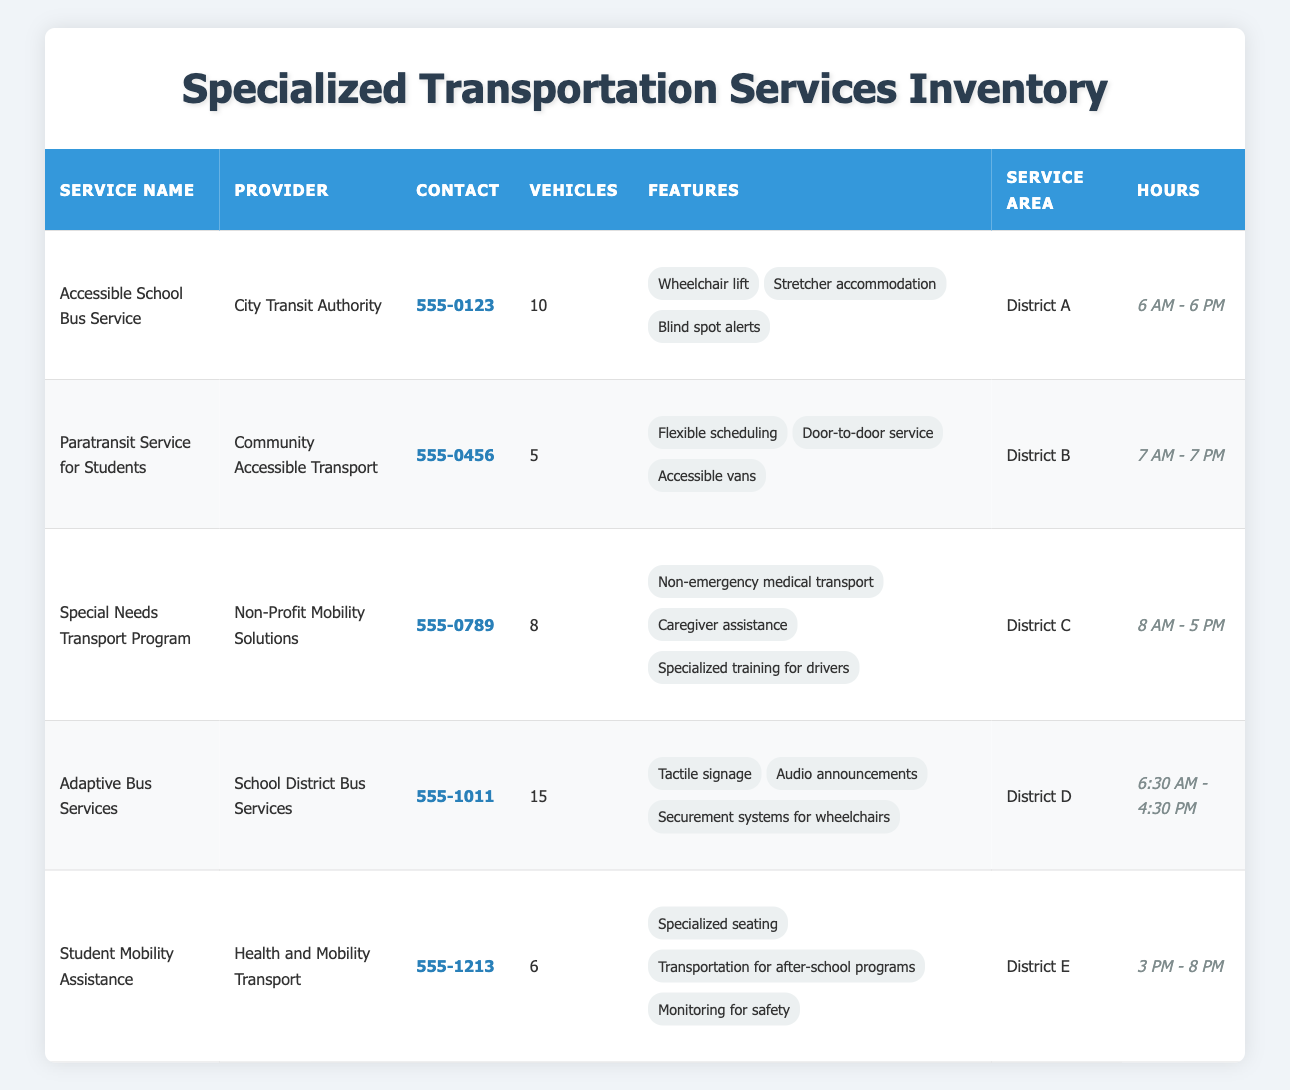What is the contact number for the "Special Needs Transport Program"? The table lists the contact numbers for each service. For the "Special Needs Transport Program," the contact number is located in the corresponding row under the "Contact" column. It is 555-0789.
Answer: 555-0789 How many vehicles are available in total across all specialized transportation services? To find the total number of vehicles, we add the vehicle counts from each service: 10 (Accessible School Bus Service) + 5 (Paratransit Service for Students) + 8 (Special Needs Transport Program) + 15 (Adaptive Bus Services) + 6 (Student Mobility Assistance) = 44.
Answer: 44 Is there a service that operates after 6 PM? Looking at the "Service Hours" column, we review each service. The only service operating after 6 PM is "Student Mobility Assistance," which operates from 3 PM to 8 PM. Therefore, the answer is yes.
Answer: Yes What is the average number of vehicles per service? First, we determine the total number of vehicles (44) and divide it by the number of services, which is 5. Thus, the average number is 44 / 5 = 8.8.
Answer: 8.8 In which district is the "Paratransit Service for Students" provided? The information is located in the "Service Area" column. According to the table, the "Paratransit Service for Students" is provided in "District B."
Answer: District B How many services provide door-to-door transportation? Upon reviewing the table, only the "Paratransit Service for Students" explicitly mentions "door-to-door service" in its features. Therefore, only one service provides this type of transport.
Answer: 1 What is the service area of the "Accessible School Bus Service"? Checking the "Service Area" column for the "Accessible School Bus Service," we see it is provided in "District A."
Answer: District A 